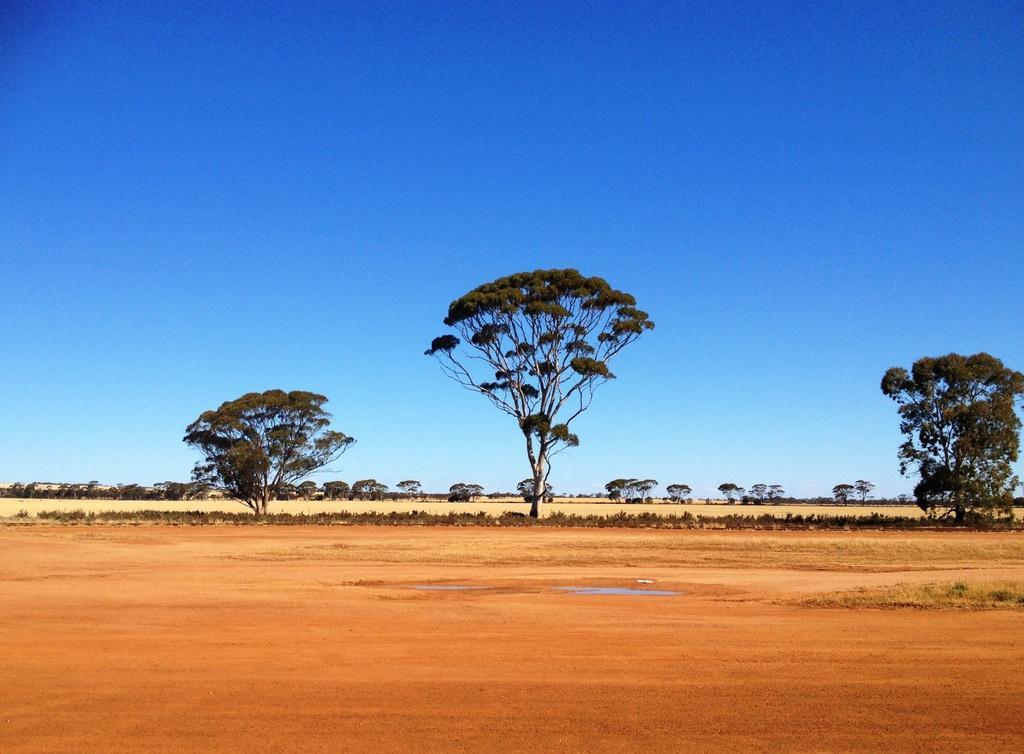Could you give a brief overview of what you see in this image? In this image we can see ground, plants, grass, and trees. In the background there is sky. 